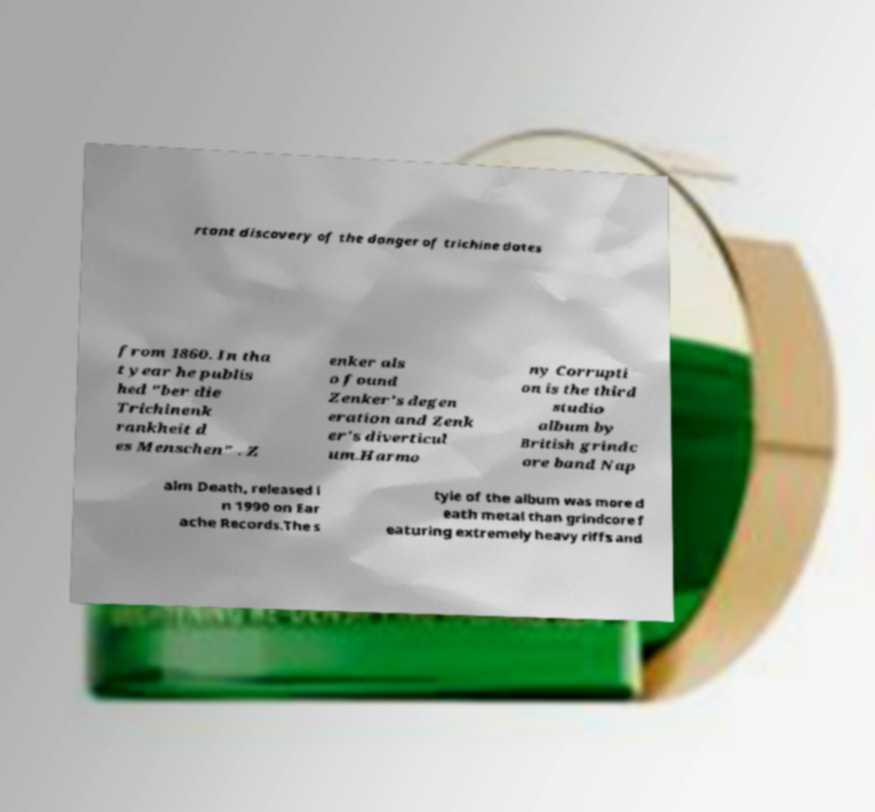I need the written content from this picture converted into text. Can you do that? rtant discovery of the danger of trichine dates from 1860. In tha t year he publis hed "ber die Trichinenk rankheit d es Menschen" . Z enker als o found Zenker's degen eration and Zenk er's diverticul um.Harmo ny Corrupti on is the third studio album by British grindc ore band Nap alm Death, released i n 1990 on Ear ache Records.The s tyle of the album was more d eath metal than grindcore f eaturing extremely heavy riffs and 